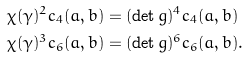<formula> <loc_0><loc_0><loc_500><loc_500>\chi ( \gamma ) ^ { 2 } c _ { 4 } ( a , b ) & = ( \det g ) ^ { 4 } c _ { 4 } ( a , b ) \\ \chi ( \gamma ) ^ { 3 } c _ { 6 } ( a , b ) & = ( \det g ) ^ { 6 } c _ { 6 } ( a , b ) .</formula> 